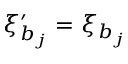<formula> <loc_0><loc_0><loc_500><loc_500>\xi _ { b _ { j } } ^ { \prime } = \xi _ { b _ { j } }</formula> 